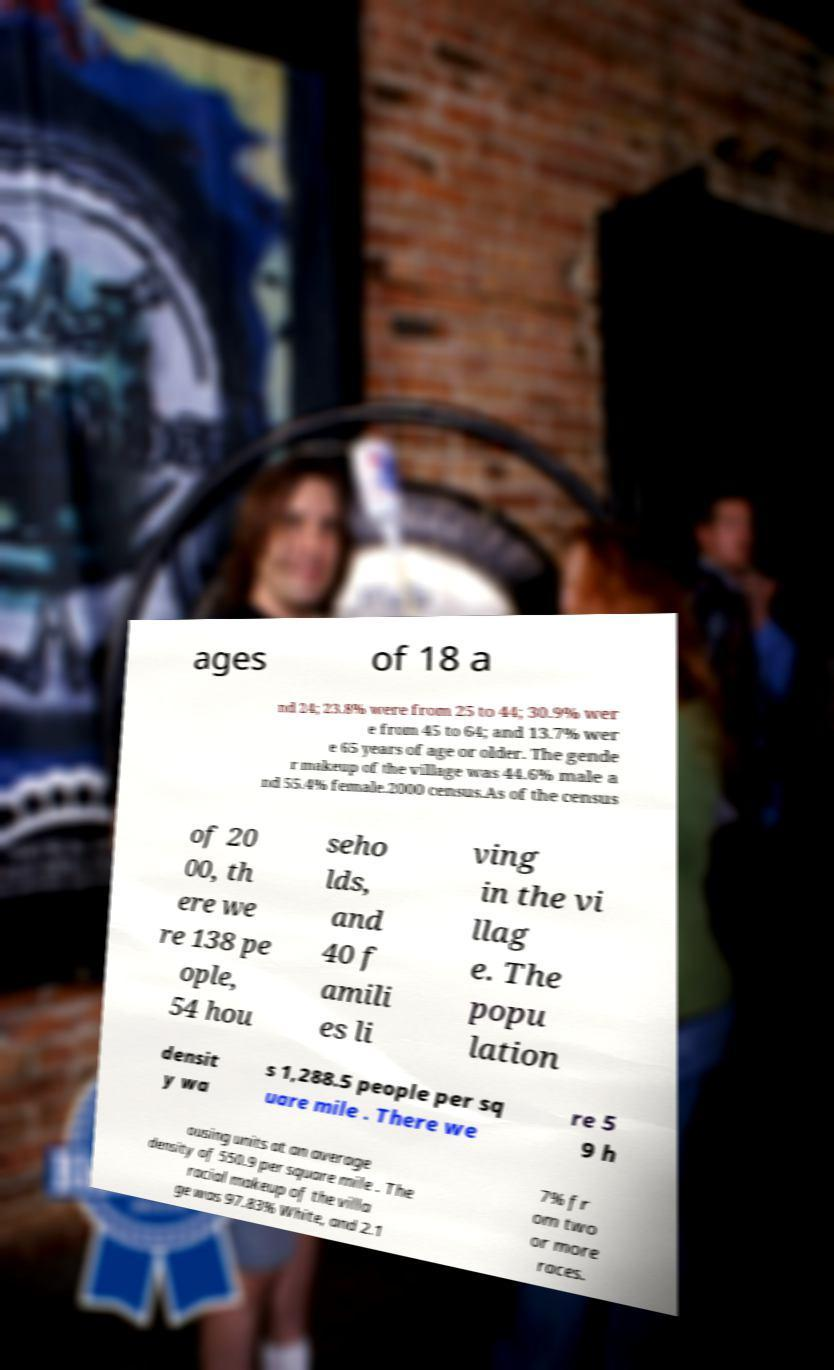Could you extract and type out the text from this image? ages of 18 a nd 24; 23.8% were from 25 to 44; 30.9% wer e from 45 to 64; and 13.7% wer e 65 years of age or older. The gende r makeup of the village was 44.6% male a nd 55.4% female.2000 census.As of the census of 20 00, th ere we re 138 pe ople, 54 hou seho lds, and 40 f amili es li ving in the vi llag e. The popu lation densit y wa s 1,288.5 people per sq uare mile . There we re 5 9 h ousing units at an average density of 550.9 per square mile . The racial makeup of the villa ge was 97.83% White, and 2.1 7% fr om two or more races. 